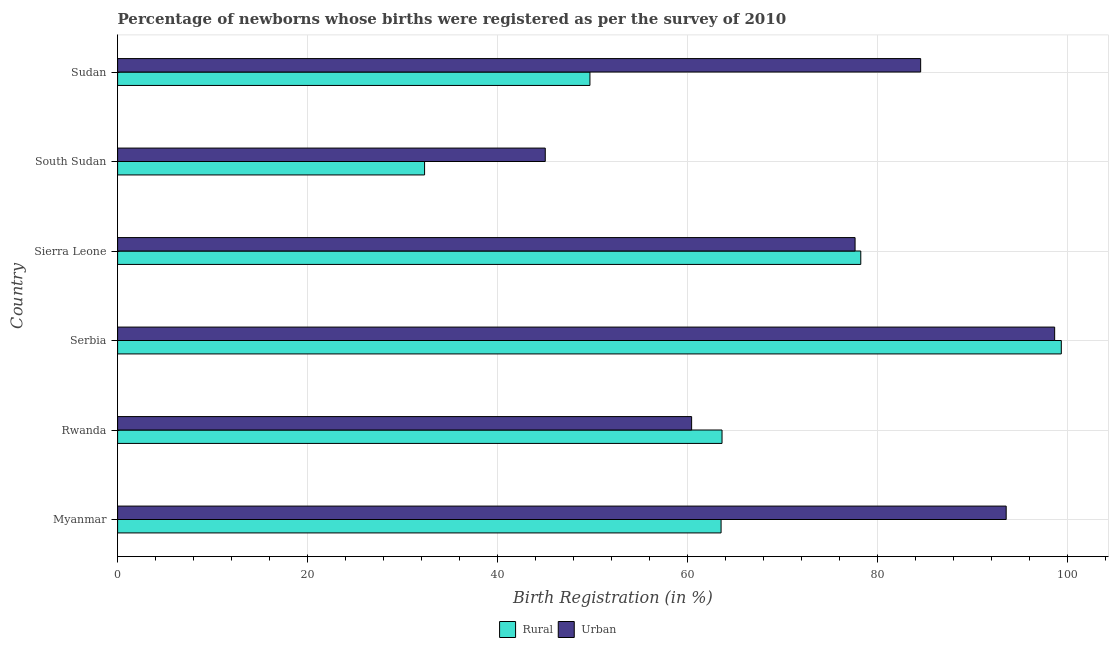How many different coloured bars are there?
Keep it short and to the point. 2. How many groups of bars are there?
Give a very brief answer. 6. Are the number of bars per tick equal to the number of legend labels?
Your answer should be compact. Yes. What is the label of the 1st group of bars from the top?
Give a very brief answer. Sudan. In how many cases, is the number of bars for a given country not equal to the number of legend labels?
Provide a short and direct response. 0. What is the urban birth registration in Sudan?
Keep it short and to the point. 84.5. Across all countries, what is the maximum rural birth registration?
Give a very brief answer. 99.3. Across all countries, what is the minimum rural birth registration?
Provide a short and direct response. 32.3. In which country was the urban birth registration maximum?
Provide a short and direct response. Serbia. In which country was the rural birth registration minimum?
Ensure brevity in your answer.  South Sudan. What is the total urban birth registration in the graph?
Ensure brevity in your answer.  459.6. What is the difference between the rural birth registration in Sierra Leone and that in South Sudan?
Keep it short and to the point. 45.9. What is the difference between the urban birth registration in Serbia and the rural birth registration in Rwanda?
Keep it short and to the point. 35. What is the average rural birth registration per country?
Provide a succinct answer. 64.43. What is the difference between the rural birth registration and urban birth registration in Sudan?
Make the answer very short. -34.8. In how many countries, is the urban birth registration greater than 100 %?
Provide a succinct answer. 0. What is the ratio of the urban birth registration in Serbia to that in Sierra Leone?
Provide a short and direct response. 1.27. Is the difference between the urban birth registration in Myanmar and Rwanda greater than the difference between the rural birth registration in Myanmar and Rwanda?
Provide a succinct answer. Yes. What is the difference between the highest and the second highest rural birth registration?
Ensure brevity in your answer.  21.1. What is the difference between the highest and the lowest urban birth registration?
Ensure brevity in your answer.  53.6. In how many countries, is the urban birth registration greater than the average urban birth registration taken over all countries?
Give a very brief answer. 4. What does the 2nd bar from the top in Sierra Leone represents?
Your answer should be compact. Rural. What does the 2nd bar from the bottom in Serbia represents?
Offer a terse response. Urban. How many bars are there?
Give a very brief answer. 12. Are the values on the major ticks of X-axis written in scientific E-notation?
Provide a short and direct response. No. How are the legend labels stacked?
Your response must be concise. Horizontal. What is the title of the graph?
Offer a terse response. Percentage of newborns whose births were registered as per the survey of 2010. What is the label or title of the X-axis?
Provide a succinct answer. Birth Registration (in %). What is the Birth Registration (in %) in Rural in Myanmar?
Provide a succinct answer. 63.5. What is the Birth Registration (in %) in Urban in Myanmar?
Provide a short and direct response. 93.5. What is the Birth Registration (in %) of Rural in Rwanda?
Keep it short and to the point. 63.6. What is the Birth Registration (in %) in Urban in Rwanda?
Give a very brief answer. 60.4. What is the Birth Registration (in %) in Rural in Serbia?
Keep it short and to the point. 99.3. What is the Birth Registration (in %) in Urban in Serbia?
Provide a succinct answer. 98.6. What is the Birth Registration (in %) of Rural in Sierra Leone?
Ensure brevity in your answer.  78.2. What is the Birth Registration (in %) in Urban in Sierra Leone?
Provide a succinct answer. 77.6. What is the Birth Registration (in %) of Rural in South Sudan?
Ensure brevity in your answer.  32.3. What is the Birth Registration (in %) of Urban in South Sudan?
Your answer should be very brief. 45. What is the Birth Registration (in %) in Rural in Sudan?
Make the answer very short. 49.7. What is the Birth Registration (in %) in Urban in Sudan?
Your response must be concise. 84.5. Across all countries, what is the maximum Birth Registration (in %) in Rural?
Give a very brief answer. 99.3. Across all countries, what is the maximum Birth Registration (in %) in Urban?
Give a very brief answer. 98.6. Across all countries, what is the minimum Birth Registration (in %) in Rural?
Offer a very short reply. 32.3. Across all countries, what is the minimum Birth Registration (in %) of Urban?
Your response must be concise. 45. What is the total Birth Registration (in %) of Rural in the graph?
Keep it short and to the point. 386.6. What is the total Birth Registration (in %) of Urban in the graph?
Your answer should be very brief. 459.6. What is the difference between the Birth Registration (in %) of Urban in Myanmar and that in Rwanda?
Make the answer very short. 33.1. What is the difference between the Birth Registration (in %) of Rural in Myanmar and that in Serbia?
Offer a terse response. -35.8. What is the difference between the Birth Registration (in %) in Rural in Myanmar and that in Sierra Leone?
Make the answer very short. -14.7. What is the difference between the Birth Registration (in %) of Rural in Myanmar and that in South Sudan?
Offer a very short reply. 31.2. What is the difference between the Birth Registration (in %) in Urban in Myanmar and that in South Sudan?
Give a very brief answer. 48.5. What is the difference between the Birth Registration (in %) of Rural in Myanmar and that in Sudan?
Offer a very short reply. 13.8. What is the difference between the Birth Registration (in %) of Rural in Rwanda and that in Serbia?
Make the answer very short. -35.7. What is the difference between the Birth Registration (in %) of Urban in Rwanda and that in Serbia?
Provide a short and direct response. -38.2. What is the difference between the Birth Registration (in %) in Rural in Rwanda and that in Sierra Leone?
Offer a very short reply. -14.6. What is the difference between the Birth Registration (in %) in Urban in Rwanda and that in Sierra Leone?
Offer a very short reply. -17.2. What is the difference between the Birth Registration (in %) in Rural in Rwanda and that in South Sudan?
Provide a short and direct response. 31.3. What is the difference between the Birth Registration (in %) in Rural in Rwanda and that in Sudan?
Make the answer very short. 13.9. What is the difference between the Birth Registration (in %) in Urban in Rwanda and that in Sudan?
Give a very brief answer. -24.1. What is the difference between the Birth Registration (in %) of Rural in Serbia and that in Sierra Leone?
Offer a very short reply. 21.1. What is the difference between the Birth Registration (in %) of Urban in Serbia and that in South Sudan?
Your response must be concise. 53.6. What is the difference between the Birth Registration (in %) of Rural in Serbia and that in Sudan?
Offer a terse response. 49.6. What is the difference between the Birth Registration (in %) of Urban in Serbia and that in Sudan?
Provide a succinct answer. 14.1. What is the difference between the Birth Registration (in %) in Rural in Sierra Leone and that in South Sudan?
Your answer should be compact. 45.9. What is the difference between the Birth Registration (in %) in Urban in Sierra Leone and that in South Sudan?
Provide a short and direct response. 32.6. What is the difference between the Birth Registration (in %) in Rural in South Sudan and that in Sudan?
Provide a succinct answer. -17.4. What is the difference between the Birth Registration (in %) of Urban in South Sudan and that in Sudan?
Ensure brevity in your answer.  -39.5. What is the difference between the Birth Registration (in %) of Rural in Myanmar and the Birth Registration (in %) of Urban in Rwanda?
Offer a terse response. 3.1. What is the difference between the Birth Registration (in %) in Rural in Myanmar and the Birth Registration (in %) in Urban in Serbia?
Offer a very short reply. -35.1. What is the difference between the Birth Registration (in %) of Rural in Myanmar and the Birth Registration (in %) of Urban in Sierra Leone?
Give a very brief answer. -14.1. What is the difference between the Birth Registration (in %) of Rural in Rwanda and the Birth Registration (in %) of Urban in Serbia?
Give a very brief answer. -35. What is the difference between the Birth Registration (in %) in Rural in Rwanda and the Birth Registration (in %) in Urban in South Sudan?
Provide a short and direct response. 18.6. What is the difference between the Birth Registration (in %) of Rural in Rwanda and the Birth Registration (in %) of Urban in Sudan?
Your response must be concise. -20.9. What is the difference between the Birth Registration (in %) of Rural in Serbia and the Birth Registration (in %) of Urban in Sierra Leone?
Keep it short and to the point. 21.7. What is the difference between the Birth Registration (in %) of Rural in Serbia and the Birth Registration (in %) of Urban in South Sudan?
Ensure brevity in your answer.  54.3. What is the difference between the Birth Registration (in %) in Rural in Serbia and the Birth Registration (in %) in Urban in Sudan?
Give a very brief answer. 14.8. What is the difference between the Birth Registration (in %) in Rural in Sierra Leone and the Birth Registration (in %) in Urban in South Sudan?
Keep it short and to the point. 33.2. What is the difference between the Birth Registration (in %) of Rural in South Sudan and the Birth Registration (in %) of Urban in Sudan?
Offer a very short reply. -52.2. What is the average Birth Registration (in %) in Rural per country?
Provide a succinct answer. 64.43. What is the average Birth Registration (in %) in Urban per country?
Ensure brevity in your answer.  76.6. What is the difference between the Birth Registration (in %) of Rural and Birth Registration (in %) of Urban in Serbia?
Provide a succinct answer. 0.7. What is the difference between the Birth Registration (in %) in Rural and Birth Registration (in %) in Urban in South Sudan?
Offer a terse response. -12.7. What is the difference between the Birth Registration (in %) of Rural and Birth Registration (in %) of Urban in Sudan?
Ensure brevity in your answer.  -34.8. What is the ratio of the Birth Registration (in %) in Rural in Myanmar to that in Rwanda?
Make the answer very short. 1. What is the ratio of the Birth Registration (in %) of Urban in Myanmar to that in Rwanda?
Ensure brevity in your answer.  1.55. What is the ratio of the Birth Registration (in %) in Rural in Myanmar to that in Serbia?
Provide a succinct answer. 0.64. What is the ratio of the Birth Registration (in %) in Urban in Myanmar to that in Serbia?
Your answer should be very brief. 0.95. What is the ratio of the Birth Registration (in %) in Rural in Myanmar to that in Sierra Leone?
Make the answer very short. 0.81. What is the ratio of the Birth Registration (in %) of Urban in Myanmar to that in Sierra Leone?
Make the answer very short. 1.2. What is the ratio of the Birth Registration (in %) of Rural in Myanmar to that in South Sudan?
Provide a succinct answer. 1.97. What is the ratio of the Birth Registration (in %) of Urban in Myanmar to that in South Sudan?
Your response must be concise. 2.08. What is the ratio of the Birth Registration (in %) of Rural in Myanmar to that in Sudan?
Your answer should be very brief. 1.28. What is the ratio of the Birth Registration (in %) in Urban in Myanmar to that in Sudan?
Your answer should be compact. 1.11. What is the ratio of the Birth Registration (in %) in Rural in Rwanda to that in Serbia?
Provide a short and direct response. 0.64. What is the ratio of the Birth Registration (in %) of Urban in Rwanda to that in Serbia?
Offer a terse response. 0.61. What is the ratio of the Birth Registration (in %) in Rural in Rwanda to that in Sierra Leone?
Offer a terse response. 0.81. What is the ratio of the Birth Registration (in %) of Urban in Rwanda to that in Sierra Leone?
Provide a succinct answer. 0.78. What is the ratio of the Birth Registration (in %) in Rural in Rwanda to that in South Sudan?
Offer a terse response. 1.97. What is the ratio of the Birth Registration (in %) of Urban in Rwanda to that in South Sudan?
Your response must be concise. 1.34. What is the ratio of the Birth Registration (in %) of Rural in Rwanda to that in Sudan?
Make the answer very short. 1.28. What is the ratio of the Birth Registration (in %) of Urban in Rwanda to that in Sudan?
Your response must be concise. 0.71. What is the ratio of the Birth Registration (in %) in Rural in Serbia to that in Sierra Leone?
Your answer should be very brief. 1.27. What is the ratio of the Birth Registration (in %) of Urban in Serbia to that in Sierra Leone?
Your answer should be compact. 1.27. What is the ratio of the Birth Registration (in %) in Rural in Serbia to that in South Sudan?
Offer a very short reply. 3.07. What is the ratio of the Birth Registration (in %) in Urban in Serbia to that in South Sudan?
Give a very brief answer. 2.19. What is the ratio of the Birth Registration (in %) in Rural in Serbia to that in Sudan?
Offer a very short reply. 2. What is the ratio of the Birth Registration (in %) of Urban in Serbia to that in Sudan?
Provide a succinct answer. 1.17. What is the ratio of the Birth Registration (in %) of Rural in Sierra Leone to that in South Sudan?
Ensure brevity in your answer.  2.42. What is the ratio of the Birth Registration (in %) of Urban in Sierra Leone to that in South Sudan?
Offer a very short reply. 1.72. What is the ratio of the Birth Registration (in %) of Rural in Sierra Leone to that in Sudan?
Provide a succinct answer. 1.57. What is the ratio of the Birth Registration (in %) in Urban in Sierra Leone to that in Sudan?
Your answer should be compact. 0.92. What is the ratio of the Birth Registration (in %) of Rural in South Sudan to that in Sudan?
Ensure brevity in your answer.  0.65. What is the ratio of the Birth Registration (in %) in Urban in South Sudan to that in Sudan?
Your response must be concise. 0.53. What is the difference between the highest and the second highest Birth Registration (in %) in Rural?
Offer a terse response. 21.1. What is the difference between the highest and the second highest Birth Registration (in %) in Urban?
Provide a short and direct response. 5.1. What is the difference between the highest and the lowest Birth Registration (in %) in Rural?
Your answer should be very brief. 67. What is the difference between the highest and the lowest Birth Registration (in %) in Urban?
Your answer should be compact. 53.6. 